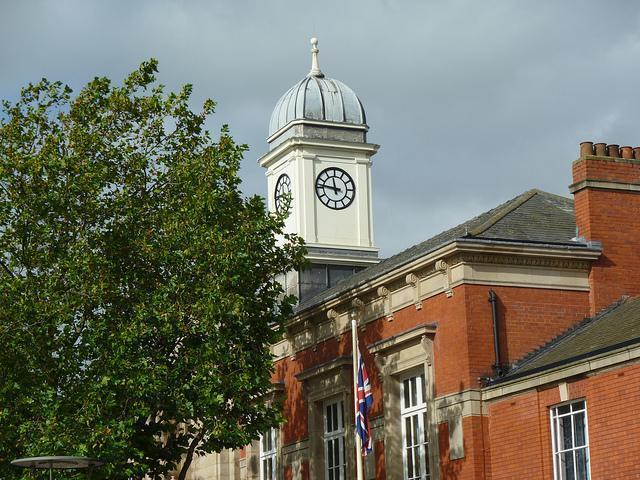How many  zebras  on there?
Give a very brief answer. 0. 